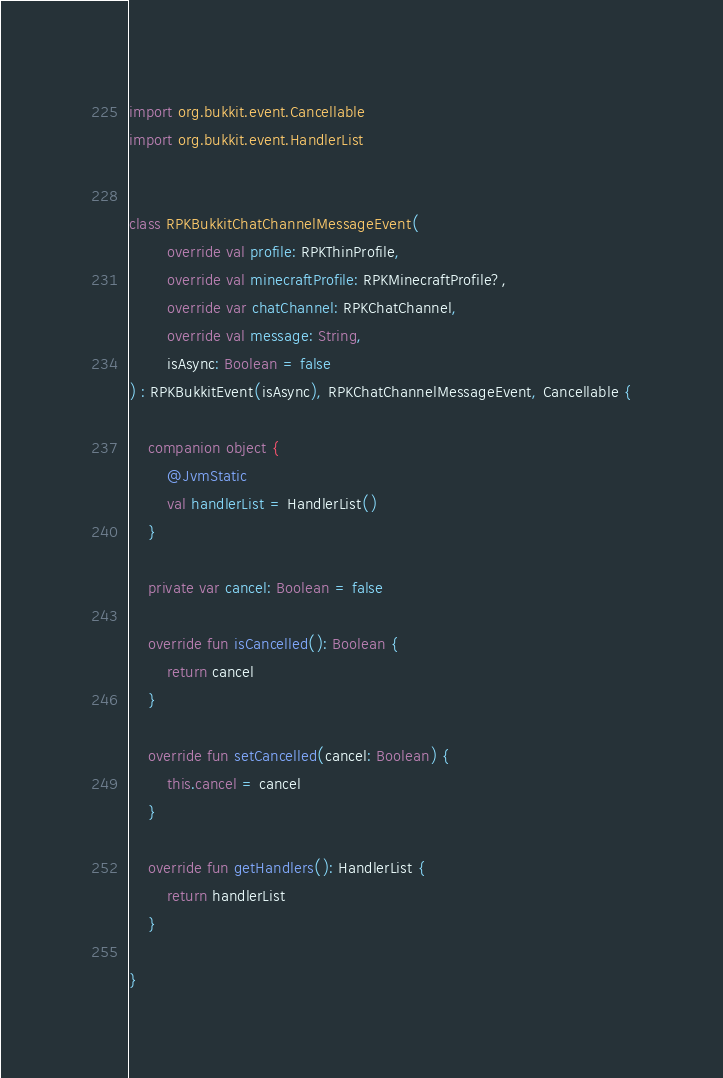Convert code to text. <code><loc_0><loc_0><loc_500><loc_500><_Kotlin_>import org.bukkit.event.Cancellable
import org.bukkit.event.HandlerList


class RPKBukkitChatChannelMessageEvent(
        override val profile: RPKThinProfile,
        override val minecraftProfile: RPKMinecraftProfile?,
        override var chatChannel: RPKChatChannel,
        override val message: String,
        isAsync: Boolean = false
) : RPKBukkitEvent(isAsync), RPKChatChannelMessageEvent, Cancellable {

    companion object {
        @JvmStatic
        val handlerList = HandlerList()
    }

    private var cancel: Boolean = false

    override fun isCancelled(): Boolean {
        return cancel
    }

    override fun setCancelled(cancel: Boolean) {
        this.cancel = cancel
    }

    override fun getHandlers(): HandlerList {
        return handlerList
    }

}</code> 